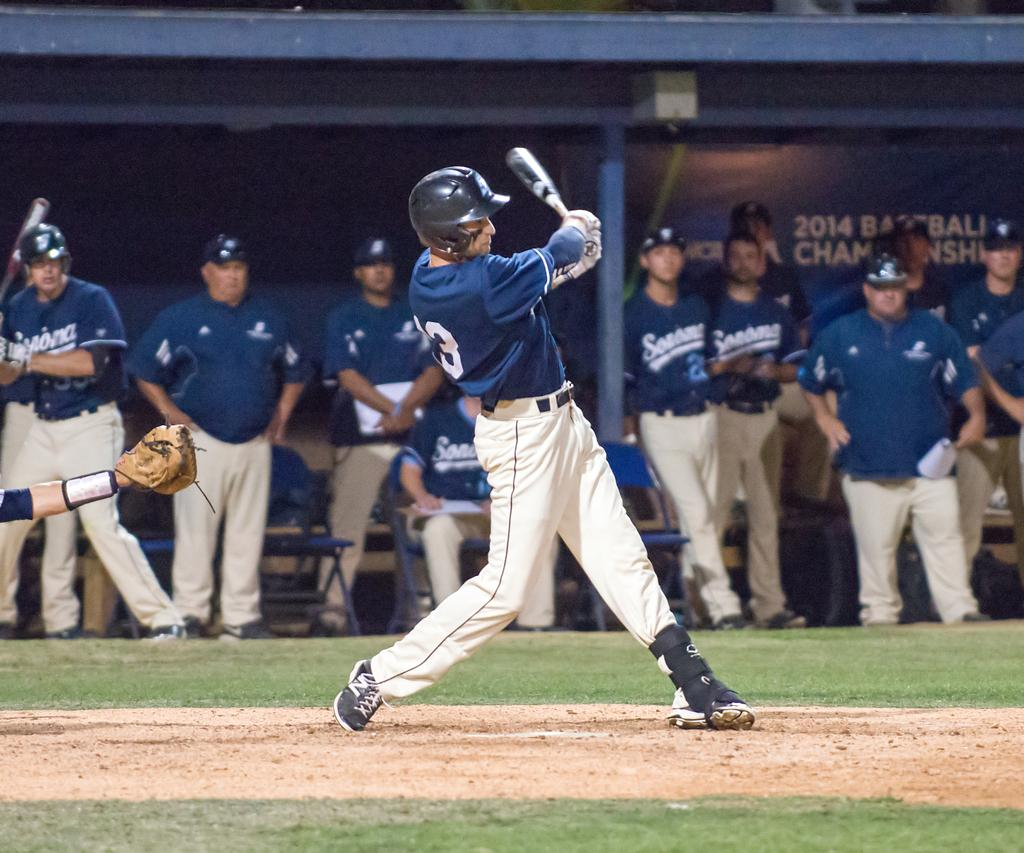Provide a one-sentence caption for the provided image. As a bater swings the number 3 is visible on the back of their uniform. 